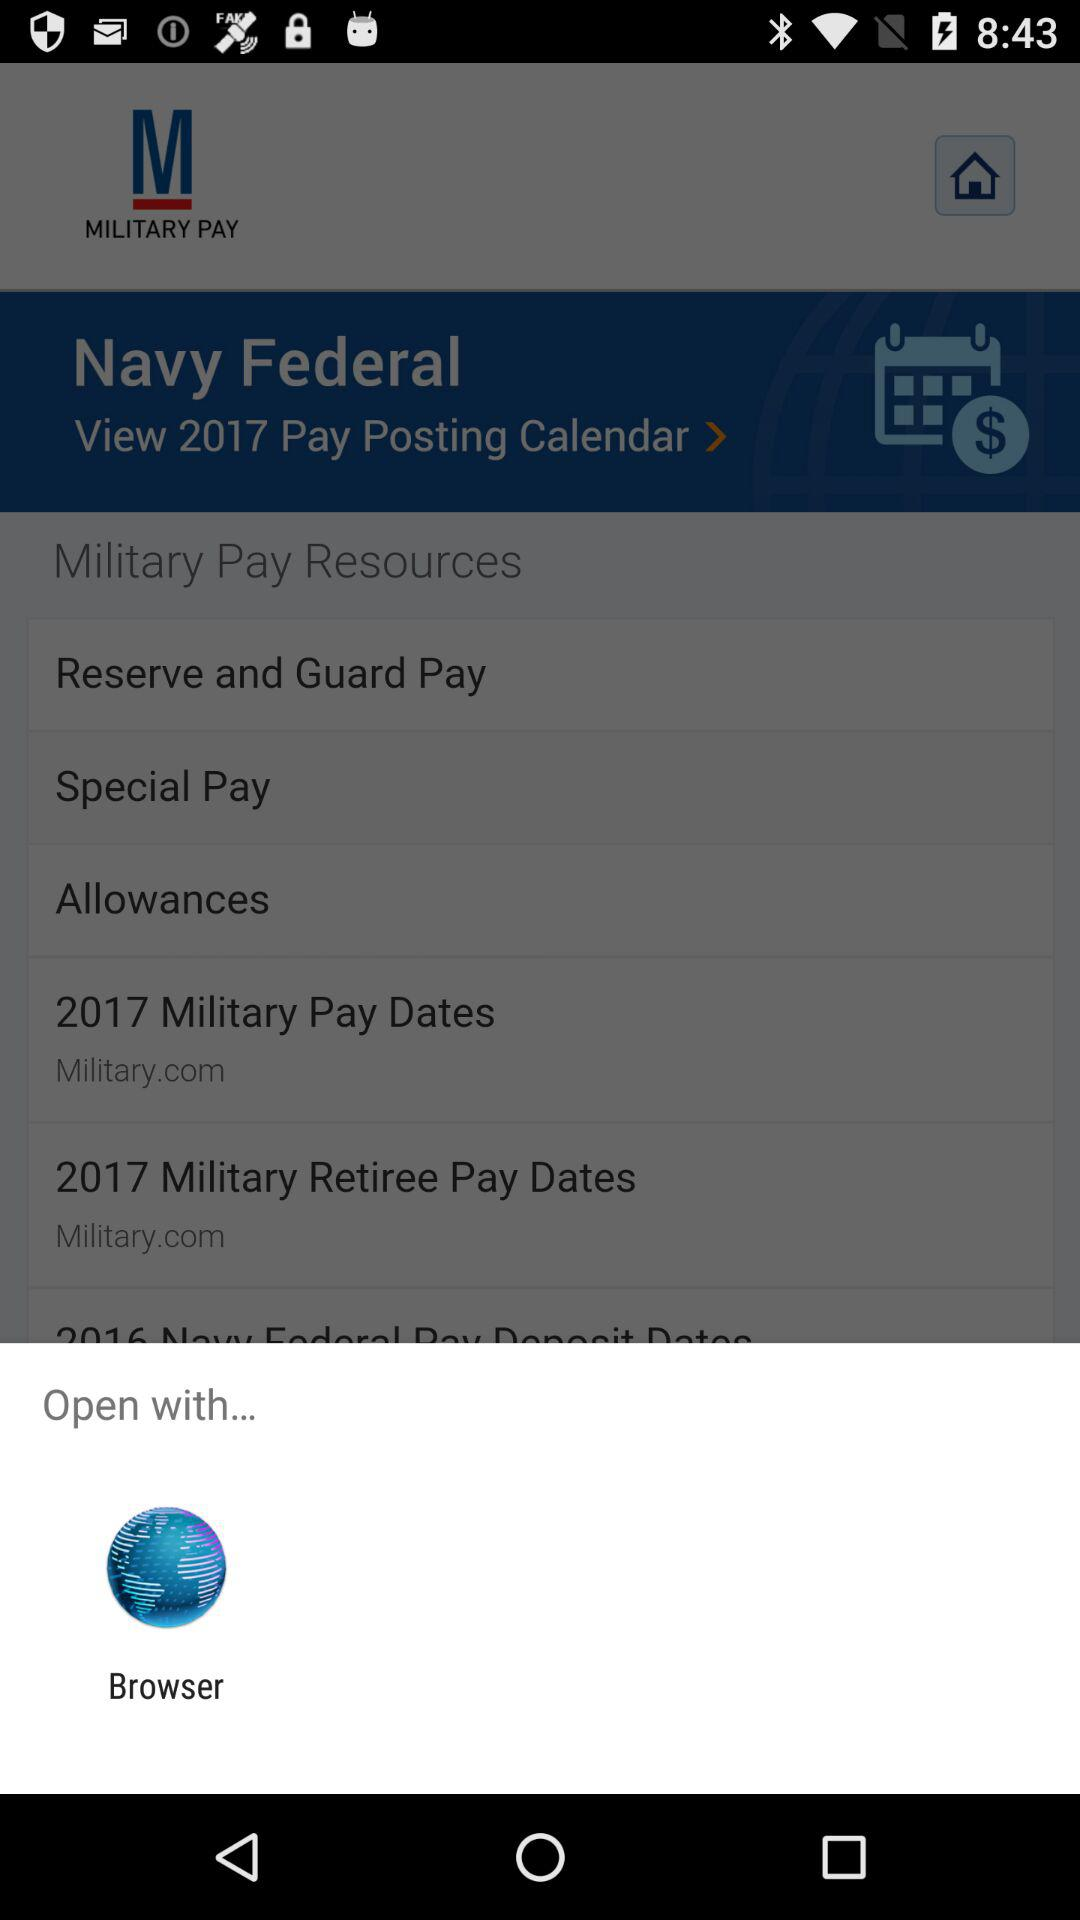Which days of the week do they get paid?
When the provided information is insufficient, respond with <no answer>. <no answer> 